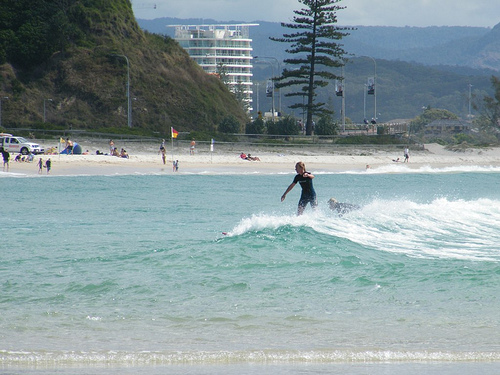Please provide a short description for this region: [0.57, 0.44, 0.66, 0.57]. The specified region [0.57, 0.44, 0.66, 0.57] of the image depicts a girl wearing a wetsuit, indicative of her readiness and attire for surfing in the ocean. 